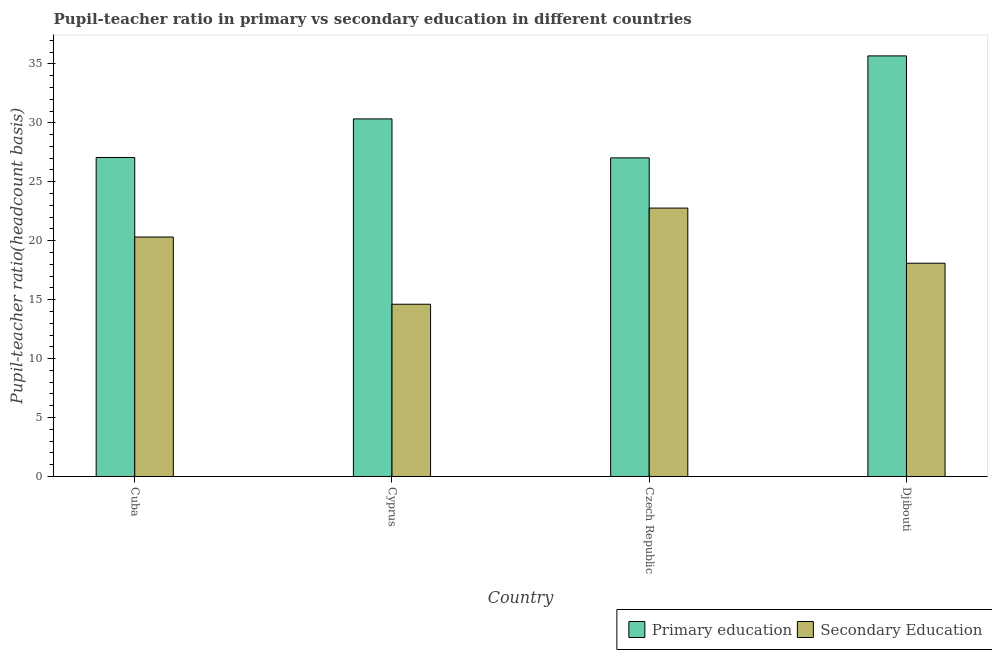How many groups of bars are there?
Provide a short and direct response. 4. Are the number of bars per tick equal to the number of legend labels?
Ensure brevity in your answer.  Yes. How many bars are there on the 3rd tick from the left?
Give a very brief answer. 2. What is the label of the 4th group of bars from the left?
Offer a terse response. Djibouti. What is the pupil-teacher ratio in primary education in Czech Republic?
Give a very brief answer. 27.03. Across all countries, what is the maximum pupil-teacher ratio in primary education?
Give a very brief answer. 35.68. Across all countries, what is the minimum pupil teacher ratio on secondary education?
Your answer should be compact. 14.61. In which country was the pupil teacher ratio on secondary education maximum?
Keep it short and to the point. Czech Republic. In which country was the pupil teacher ratio on secondary education minimum?
Your answer should be compact. Cyprus. What is the total pupil-teacher ratio in primary education in the graph?
Your response must be concise. 120.1. What is the difference between the pupil-teacher ratio in primary education in Cuba and that in Czech Republic?
Make the answer very short. 0.03. What is the difference between the pupil-teacher ratio in primary education in Cuba and the pupil teacher ratio on secondary education in Djibouti?
Offer a terse response. 8.97. What is the average pupil-teacher ratio in primary education per country?
Your response must be concise. 30.02. What is the difference between the pupil teacher ratio on secondary education and pupil-teacher ratio in primary education in Czech Republic?
Ensure brevity in your answer.  -4.26. In how many countries, is the pupil-teacher ratio in primary education greater than 12 ?
Ensure brevity in your answer.  4. What is the ratio of the pupil-teacher ratio in primary education in Cuba to that in Djibouti?
Your answer should be very brief. 0.76. Is the difference between the pupil teacher ratio on secondary education in Czech Republic and Djibouti greater than the difference between the pupil-teacher ratio in primary education in Czech Republic and Djibouti?
Give a very brief answer. Yes. What is the difference between the highest and the second highest pupil-teacher ratio in primary education?
Your response must be concise. 5.34. What is the difference between the highest and the lowest pupil teacher ratio on secondary education?
Your response must be concise. 8.16. In how many countries, is the pupil teacher ratio on secondary education greater than the average pupil teacher ratio on secondary education taken over all countries?
Offer a terse response. 2. Is the sum of the pupil teacher ratio on secondary education in Cuba and Djibouti greater than the maximum pupil-teacher ratio in primary education across all countries?
Provide a succinct answer. Yes. How many bars are there?
Offer a very short reply. 8. Are all the bars in the graph horizontal?
Your answer should be very brief. No. How many countries are there in the graph?
Give a very brief answer. 4. What is the difference between two consecutive major ticks on the Y-axis?
Give a very brief answer. 5. Are the values on the major ticks of Y-axis written in scientific E-notation?
Your answer should be very brief. No. Where does the legend appear in the graph?
Give a very brief answer. Bottom right. What is the title of the graph?
Your response must be concise. Pupil-teacher ratio in primary vs secondary education in different countries. What is the label or title of the X-axis?
Provide a short and direct response. Country. What is the label or title of the Y-axis?
Make the answer very short. Pupil-teacher ratio(headcount basis). What is the Pupil-teacher ratio(headcount basis) of Primary education in Cuba?
Keep it short and to the point. 27.06. What is the Pupil-teacher ratio(headcount basis) of Secondary Education in Cuba?
Your answer should be very brief. 20.31. What is the Pupil-teacher ratio(headcount basis) in Primary education in Cyprus?
Offer a very short reply. 30.33. What is the Pupil-teacher ratio(headcount basis) of Secondary Education in Cyprus?
Your answer should be very brief. 14.61. What is the Pupil-teacher ratio(headcount basis) in Primary education in Czech Republic?
Keep it short and to the point. 27.03. What is the Pupil-teacher ratio(headcount basis) of Secondary Education in Czech Republic?
Give a very brief answer. 22.77. What is the Pupil-teacher ratio(headcount basis) in Primary education in Djibouti?
Provide a succinct answer. 35.68. What is the Pupil-teacher ratio(headcount basis) in Secondary Education in Djibouti?
Your answer should be very brief. 18.09. Across all countries, what is the maximum Pupil-teacher ratio(headcount basis) in Primary education?
Provide a succinct answer. 35.68. Across all countries, what is the maximum Pupil-teacher ratio(headcount basis) of Secondary Education?
Provide a short and direct response. 22.77. Across all countries, what is the minimum Pupil-teacher ratio(headcount basis) in Primary education?
Your answer should be very brief. 27.03. Across all countries, what is the minimum Pupil-teacher ratio(headcount basis) in Secondary Education?
Give a very brief answer. 14.61. What is the total Pupil-teacher ratio(headcount basis) in Primary education in the graph?
Your response must be concise. 120.1. What is the total Pupil-teacher ratio(headcount basis) in Secondary Education in the graph?
Give a very brief answer. 75.78. What is the difference between the Pupil-teacher ratio(headcount basis) of Primary education in Cuba and that in Cyprus?
Offer a terse response. -3.27. What is the difference between the Pupil-teacher ratio(headcount basis) in Secondary Education in Cuba and that in Cyprus?
Make the answer very short. 5.7. What is the difference between the Pupil-teacher ratio(headcount basis) of Primary education in Cuba and that in Czech Republic?
Your response must be concise. 0.03. What is the difference between the Pupil-teacher ratio(headcount basis) of Secondary Education in Cuba and that in Czech Republic?
Your answer should be very brief. -2.45. What is the difference between the Pupil-teacher ratio(headcount basis) in Primary education in Cuba and that in Djibouti?
Keep it short and to the point. -8.62. What is the difference between the Pupil-teacher ratio(headcount basis) in Secondary Education in Cuba and that in Djibouti?
Provide a short and direct response. 2.22. What is the difference between the Pupil-teacher ratio(headcount basis) in Primary education in Cyprus and that in Czech Republic?
Provide a succinct answer. 3.31. What is the difference between the Pupil-teacher ratio(headcount basis) of Secondary Education in Cyprus and that in Czech Republic?
Ensure brevity in your answer.  -8.16. What is the difference between the Pupil-teacher ratio(headcount basis) in Primary education in Cyprus and that in Djibouti?
Make the answer very short. -5.34. What is the difference between the Pupil-teacher ratio(headcount basis) in Secondary Education in Cyprus and that in Djibouti?
Offer a very short reply. -3.48. What is the difference between the Pupil-teacher ratio(headcount basis) of Primary education in Czech Republic and that in Djibouti?
Provide a short and direct response. -8.65. What is the difference between the Pupil-teacher ratio(headcount basis) in Secondary Education in Czech Republic and that in Djibouti?
Give a very brief answer. 4.68. What is the difference between the Pupil-teacher ratio(headcount basis) of Primary education in Cuba and the Pupil-teacher ratio(headcount basis) of Secondary Education in Cyprus?
Make the answer very short. 12.45. What is the difference between the Pupil-teacher ratio(headcount basis) of Primary education in Cuba and the Pupil-teacher ratio(headcount basis) of Secondary Education in Czech Republic?
Give a very brief answer. 4.29. What is the difference between the Pupil-teacher ratio(headcount basis) of Primary education in Cuba and the Pupil-teacher ratio(headcount basis) of Secondary Education in Djibouti?
Your response must be concise. 8.97. What is the difference between the Pupil-teacher ratio(headcount basis) in Primary education in Cyprus and the Pupil-teacher ratio(headcount basis) in Secondary Education in Czech Republic?
Offer a terse response. 7.57. What is the difference between the Pupil-teacher ratio(headcount basis) of Primary education in Cyprus and the Pupil-teacher ratio(headcount basis) of Secondary Education in Djibouti?
Your response must be concise. 12.24. What is the difference between the Pupil-teacher ratio(headcount basis) of Primary education in Czech Republic and the Pupil-teacher ratio(headcount basis) of Secondary Education in Djibouti?
Make the answer very short. 8.94. What is the average Pupil-teacher ratio(headcount basis) in Primary education per country?
Your response must be concise. 30.02. What is the average Pupil-teacher ratio(headcount basis) in Secondary Education per country?
Give a very brief answer. 18.95. What is the difference between the Pupil-teacher ratio(headcount basis) in Primary education and Pupil-teacher ratio(headcount basis) in Secondary Education in Cuba?
Your response must be concise. 6.75. What is the difference between the Pupil-teacher ratio(headcount basis) in Primary education and Pupil-teacher ratio(headcount basis) in Secondary Education in Cyprus?
Keep it short and to the point. 15.72. What is the difference between the Pupil-teacher ratio(headcount basis) of Primary education and Pupil-teacher ratio(headcount basis) of Secondary Education in Czech Republic?
Give a very brief answer. 4.26. What is the difference between the Pupil-teacher ratio(headcount basis) in Primary education and Pupil-teacher ratio(headcount basis) in Secondary Education in Djibouti?
Provide a succinct answer. 17.59. What is the ratio of the Pupil-teacher ratio(headcount basis) of Primary education in Cuba to that in Cyprus?
Offer a very short reply. 0.89. What is the ratio of the Pupil-teacher ratio(headcount basis) of Secondary Education in Cuba to that in Cyprus?
Your response must be concise. 1.39. What is the ratio of the Pupil-teacher ratio(headcount basis) of Secondary Education in Cuba to that in Czech Republic?
Your response must be concise. 0.89. What is the ratio of the Pupil-teacher ratio(headcount basis) of Primary education in Cuba to that in Djibouti?
Provide a short and direct response. 0.76. What is the ratio of the Pupil-teacher ratio(headcount basis) in Secondary Education in Cuba to that in Djibouti?
Your response must be concise. 1.12. What is the ratio of the Pupil-teacher ratio(headcount basis) of Primary education in Cyprus to that in Czech Republic?
Provide a succinct answer. 1.12. What is the ratio of the Pupil-teacher ratio(headcount basis) in Secondary Education in Cyprus to that in Czech Republic?
Your answer should be very brief. 0.64. What is the ratio of the Pupil-teacher ratio(headcount basis) in Primary education in Cyprus to that in Djibouti?
Your response must be concise. 0.85. What is the ratio of the Pupil-teacher ratio(headcount basis) in Secondary Education in Cyprus to that in Djibouti?
Keep it short and to the point. 0.81. What is the ratio of the Pupil-teacher ratio(headcount basis) in Primary education in Czech Republic to that in Djibouti?
Your answer should be compact. 0.76. What is the ratio of the Pupil-teacher ratio(headcount basis) in Secondary Education in Czech Republic to that in Djibouti?
Keep it short and to the point. 1.26. What is the difference between the highest and the second highest Pupil-teacher ratio(headcount basis) of Primary education?
Keep it short and to the point. 5.34. What is the difference between the highest and the second highest Pupil-teacher ratio(headcount basis) in Secondary Education?
Keep it short and to the point. 2.45. What is the difference between the highest and the lowest Pupil-teacher ratio(headcount basis) of Primary education?
Give a very brief answer. 8.65. What is the difference between the highest and the lowest Pupil-teacher ratio(headcount basis) in Secondary Education?
Offer a very short reply. 8.16. 